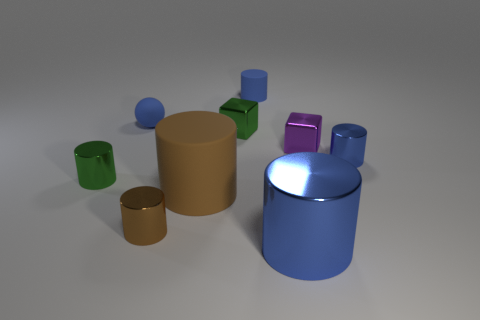Is there any other thing that is the same shape as the purple thing?
Provide a succinct answer. Yes. The matte thing in front of the small blue metal cylinder that is in front of the cube on the left side of the purple object is what color?
Provide a succinct answer. Brown. How many small things are either blue things or blocks?
Give a very brief answer. 5. Are there an equal number of tiny metallic objects that are behind the tiny rubber cylinder and small green shiny cubes?
Keep it short and to the point. No. Are there any metal cylinders right of the big brown object?
Your answer should be compact. Yes. How many metallic objects are either tiny purple cylinders or tiny spheres?
Make the answer very short. 0. There is a tiny purple metal cube; what number of small blue metallic cylinders are in front of it?
Provide a succinct answer. 1. Is there a gray object that has the same size as the green shiny cube?
Offer a terse response. No. Are there any shiny things of the same color as the large rubber thing?
Provide a short and direct response. Yes. What number of tiny things are the same color as the large metallic cylinder?
Provide a succinct answer. 3. 